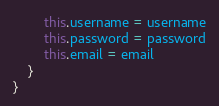<code> <loc_0><loc_0><loc_500><loc_500><_TypeScript_>        this.username = username
        this.password = password
        this.email = email
    }
}</code> 